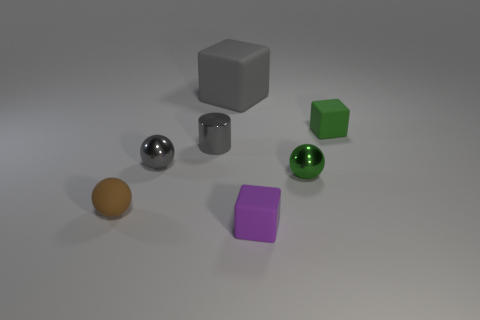What is the size of the sphere that is on the left side of the gray cube and in front of the tiny gray ball?
Your answer should be very brief. Small. Are any small brown matte objects visible?
Provide a succinct answer. Yes. How many other objects are the same size as the green metal ball?
Keep it short and to the point. 5. There is a metallic sphere right of the large gray rubber thing; does it have the same color as the small rubber thing to the right of the purple cube?
Your response must be concise. Yes. There is a purple object that is the same shape as the large gray object; what size is it?
Give a very brief answer. Small. Is the material of the green thing behind the metal cylinder the same as the tiny gray object that is in front of the cylinder?
Keep it short and to the point. No. What number of matte things are cylinders or small yellow cylinders?
Ensure brevity in your answer.  0. There is a tiny green thing behind the green thing that is in front of the tiny cube that is behind the small shiny cylinder; what is it made of?
Your answer should be very brief. Rubber. Is the shape of the tiny metallic object on the right side of the large gray matte object the same as the tiny rubber object left of the purple matte cube?
Ensure brevity in your answer.  Yes. There is a metallic object that is right of the rubber block that is behind the green block; what is its color?
Make the answer very short. Green. 